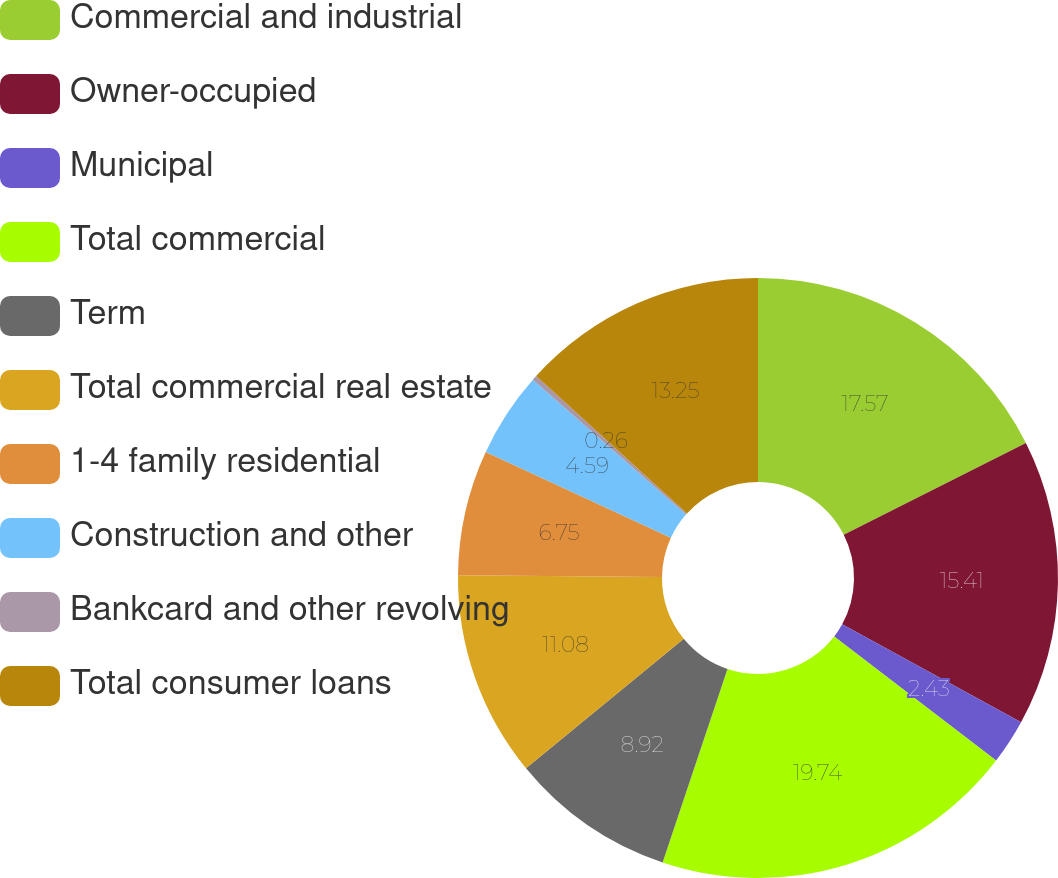Convert chart. <chart><loc_0><loc_0><loc_500><loc_500><pie_chart><fcel>Commercial and industrial<fcel>Owner-occupied<fcel>Municipal<fcel>Total commercial<fcel>Term<fcel>Total commercial real estate<fcel>1-4 family residential<fcel>Construction and other<fcel>Bankcard and other revolving<fcel>Total consumer loans<nl><fcel>17.57%<fcel>15.41%<fcel>2.43%<fcel>19.74%<fcel>8.92%<fcel>11.08%<fcel>6.75%<fcel>4.59%<fcel>0.26%<fcel>13.25%<nl></chart> 